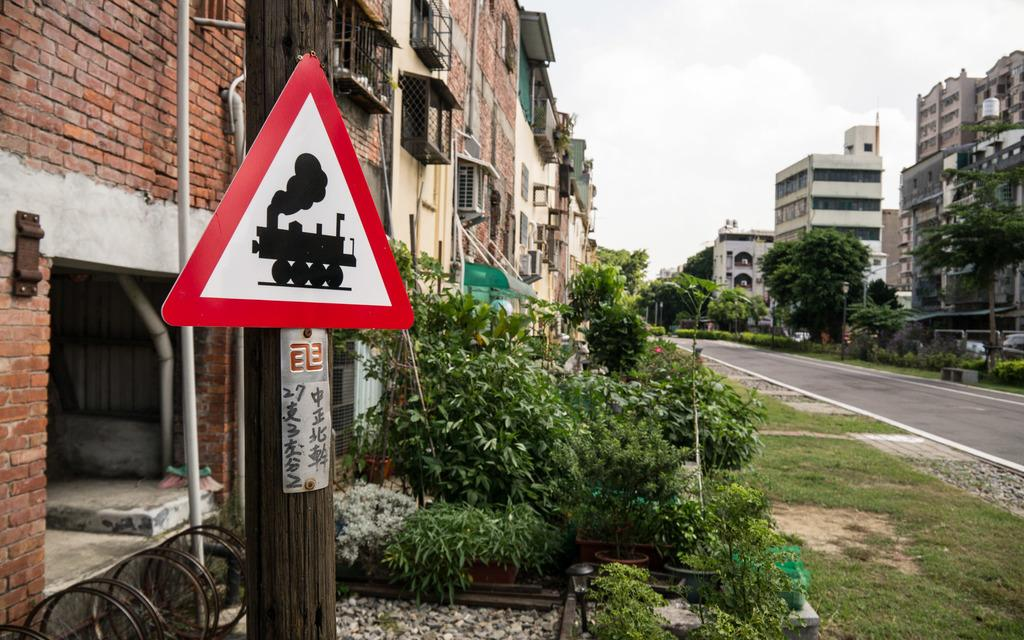<image>
Create a compact narrative representing the image presented. A steam locomotive ahead warning sign is in the foreground of this image taken on a quiet city street near a large brick building and several green shrubs. 